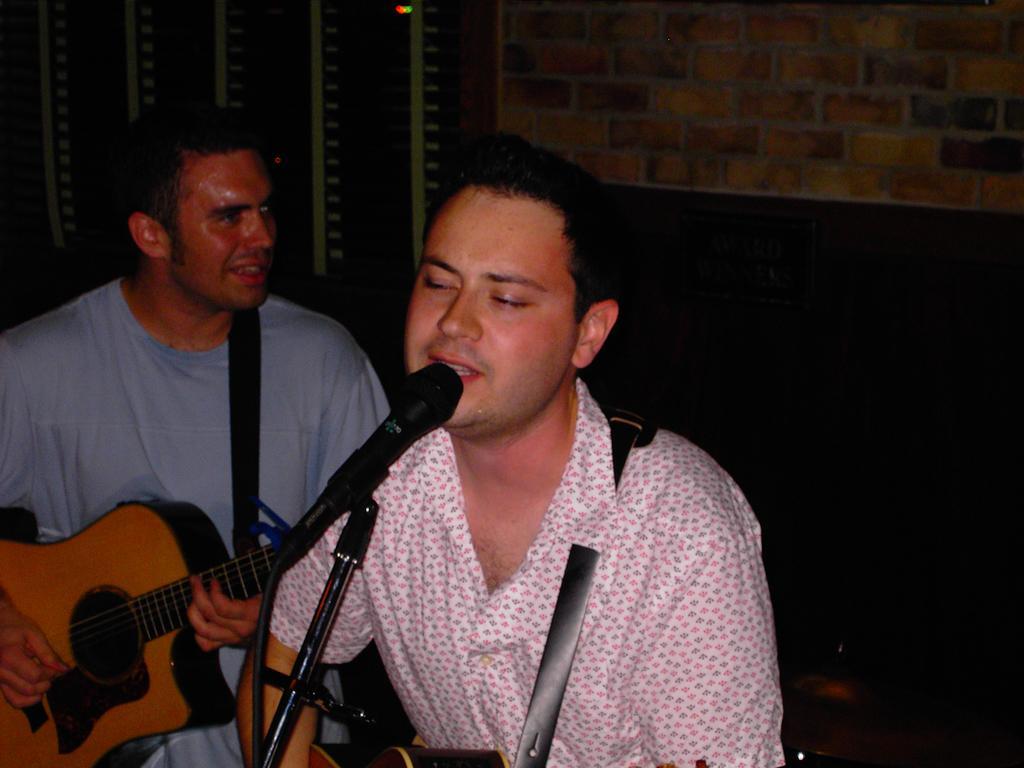Please provide a concise description of this image. This is picture inside the room. There are two persons standing and playing guitar and singing. At the front there is a microphone. 